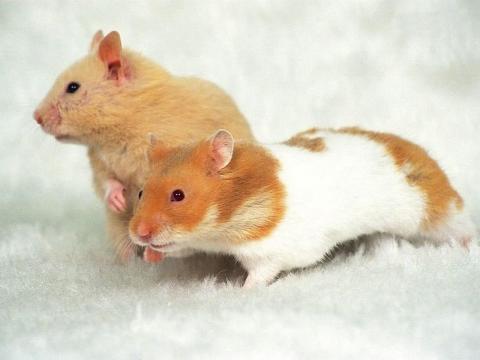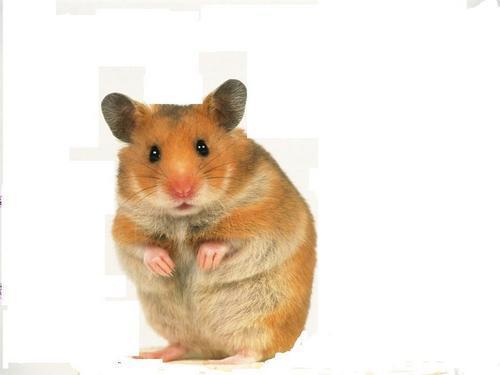The first image is the image on the left, the second image is the image on the right. Given the left and right images, does the statement "There are exactly two hamsters in total." hold true? Answer yes or no. No. 